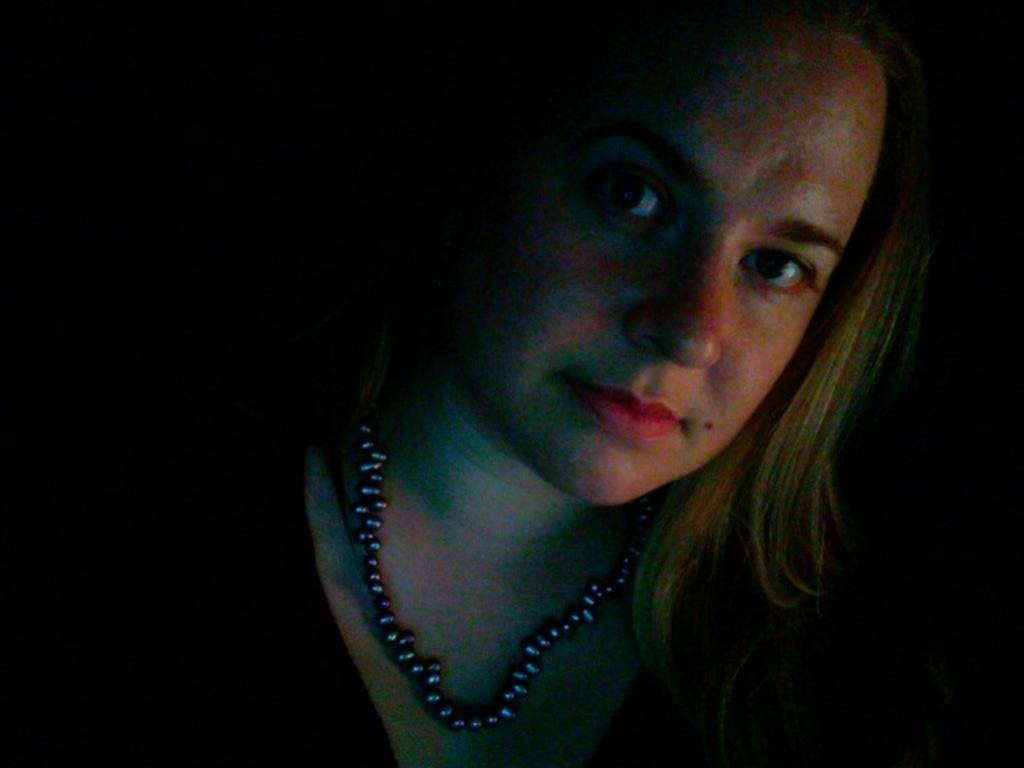Who is the main subject in the image? There is a woman in the image. What is the woman wearing around her neck? The woman is wearing an ornament around her neck. What can be observed about the background of the image? The background of the image is dark in color. What type of collar is the woman wearing in the image? The woman is not wearing a collar in the image; she is wearing an ornament around her neck. 